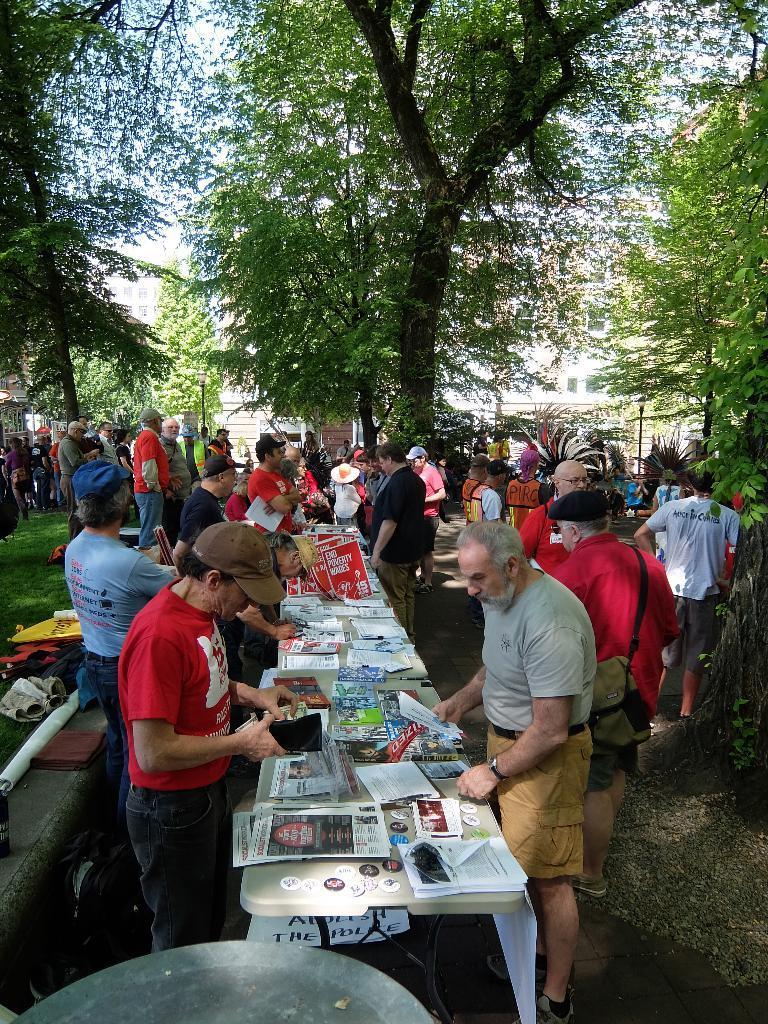How would you summarize this image in a sentence or two? In this image in the center there is a table and on the table there are papers and there are persons standing in the center. In the background there are trees, there are buildings and on the left there is grass on the ground and there are objects on the ground. 